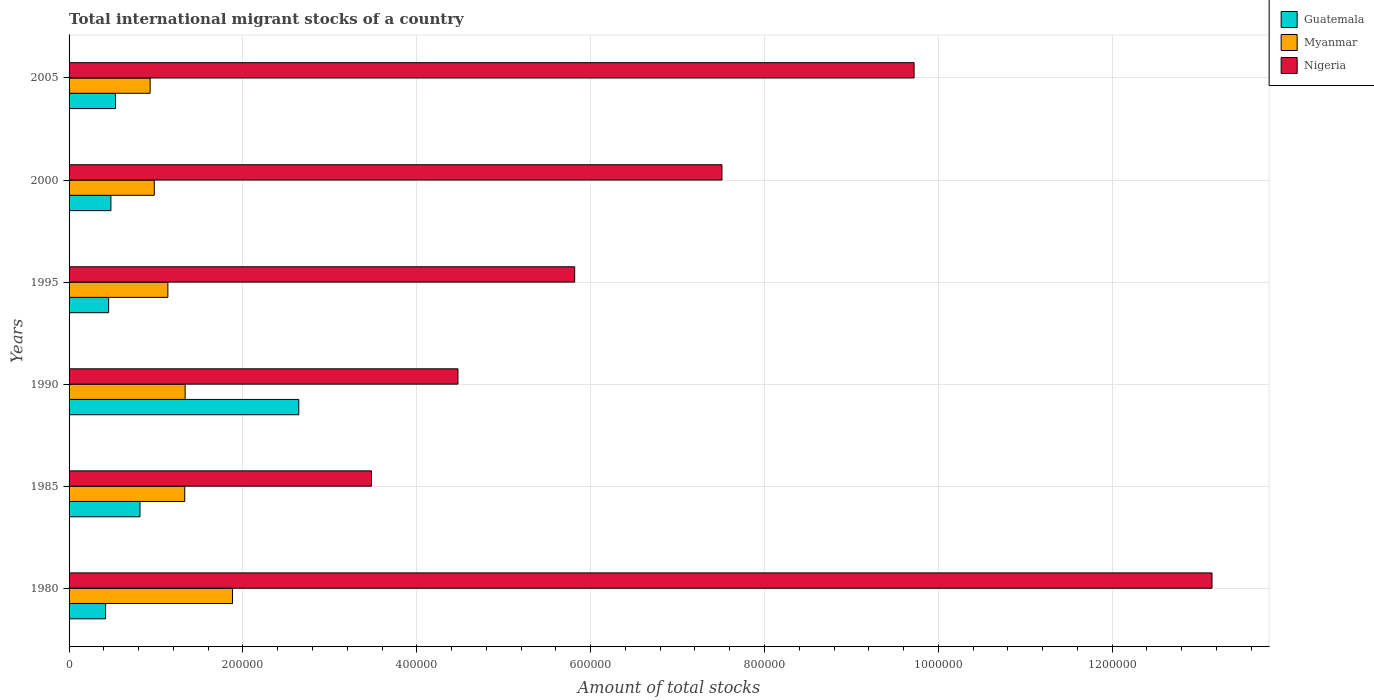Are the number of bars per tick equal to the number of legend labels?
Give a very brief answer. Yes. How many bars are there on the 2nd tick from the bottom?
Keep it short and to the point. 3. What is the label of the 2nd group of bars from the top?
Make the answer very short. 2000. What is the amount of total stocks in in Myanmar in 1990?
Offer a terse response. 1.34e+05. Across all years, what is the maximum amount of total stocks in in Guatemala?
Offer a terse response. 2.64e+05. Across all years, what is the minimum amount of total stocks in in Guatemala?
Give a very brief answer. 4.20e+04. In which year was the amount of total stocks in in Guatemala minimum?
Your response must be concise. 1980. What is the total amount of total stocks in in Nigeria in the graph?
Provide a succinct answer. 4.42e+06. What is the difference between the amount of total stocks in in Guatemala in 2000 and that in 2005?
Offer a terse response. -5318. What is the difference between the amount of total stocks in in Myanmar in 1980 and the amount of total stocks in in Nigeria in 2000?
Keep it short and to the point. -5.63e+05. What is the average amount of total stocks in in Guatemala per year?
Make the answer very short. 8.92e+04. In the year 1980, what is the difference between the amount of total stocks in in Nigeria and amount of total stocks in in Myanmar?
Ensure brevity in your answer.  1.13e+06. What is the ratio of the amount of total stocks in in Nigeria in 1990 to that in 2005?
Give a very brief answer. 0.46. Is the difference between the amount of total stocks in in Nigeria in 1990 and 2000 greater than the difference between the amount of total stocks in in Myanmar in 1990 and 2000?
Keep it short and to the point. No. What is the difference between the highest and the second highest amount of total stocks in in Nigeria?
Your response must be concise. 3.43e+05. What is the difference between the highest and the lowest amount of total stocks in in Guatemala?
Keep it short and to the point. 2.22e+05. In how many years, is the amount of total stocks in in Nigeria greater than the average amount of total stocks in in Nigeria taken over all years?
Give a very brief answer. 3. What does the 2nd bar from the top in 1980 represents?
Make the answer very short. Myanmar. What does the 2nd bar from the bottom in 2005 represents?
Keep it short and to the point. Myanmar. How many bars are there?
Your response must be concise. 18. Are the values on the major ticks of X-axis written in scientific E-notation?
Your answer should be compact. No. Does the graph contain any zero values?
Make the answer very short. No. Does the graph contain grids?
Your answer should be compact. Yes. Where does the legend appear in the graph?
Provide a short and direct response. Top right. How many legend labels are there?
Your answer should be compact. 3. What is the title of the graph?
Your response must be concise. Total international migrant stocks of a country. Does "Uzbekistan" appear as one of the legend labels in the graph?
Your answer should be very brief. No. What is the label or title of the X-axis?
Offer a terse response. Amount of total stocks. What is the Amount of total stocks of Guatemala in 1980?
Your answer should be very brief. 4.20e+04. What is the Amount of total stocks in Myanmar in 1980?
Provide a succinct answer. 1.88e+05. What is the Amount of total stocks of Nigeria in 1980?
Your response must be concise. 1.31e+06. What is the Amount of total stocks in Guatemala in 1985?
Keep it short and to the point. 8.16e+04. What is the Amount of total stocks in Myanmar in 1985?
Make the answer very short. 1.33e+05. What is the Amount of total stocks in Nigeria in 1985?
Provide a short and direct response. 3.48e+05. What is the Amount of total stocks in Guatemala in 1990?
Keep it short and to the point. 2.64e+05. What is the Amount of total stocks of Myanmar in 1990?
Your response must be concise. 1.34e+05. What is the Amount of total stocks of Nigeria in 1990?
Keep it short and to the point. 4.47e+05. What is the Amount of total stocks of Guatemala in 1995?
Your answer should be very brief. 4.55e+04. What is the Amount of total stocks of Myanmar in 1995?
Your response must be concise. 1.14e+05. What is the Amount of total stocks of Nigeria in 1995?
Ensure brevity in your answer.  5.82e+05. What is the Amount of total stocks of Guatemala in 2000?
Give a very brief answer. 4.81e+04. What is the Amount of total stocks in Myanmar in 2000?
Ensure brevity in your answer.  9.80e+04. What is the Amount of total stocks in Nigeria in 2000?
Offer a terse response. 7.51e+05. What is the Amount of total stocks of Guatemala in 2005?
Give a very brief answer. 5.34e+04. What is the Amount of total stocks in Myanmar in 2005?
Offer a terse response. 9.32e+04. What is the Amount of total stocks of Nigeria in 2005?
Your response must be concise. 9.72e+05. Across all years, what is the maximum Amount of total stocks of Guatemala?
Keep it short and to the point. 2.64e+05. Across all years, what is the maximum Amount of total stocks of Myanmar?
Keep it short and to the point. 1.88e+05. Across all years, what is the maximum Amount of total stocks in Nigeria?
Your response must be concise. 1.31e+06. Across all years, what is the minimum Amount of total stocks in Guatemala?
Your answer should be compact. 4.20e+04. Across all years, what is the minimum Amount of total stocks in Myanmar?
Make the answer very short. 9.32e+04. Across all years, what is the minimum Amount of total stocks of Nigeria?
Keep it short and to the point. 3.48e+05. What is the total Amount of total stocks of Guatemala in the graph?
Offer a terse response. 5.35e+05. What is the total Amount of total stocks of Myanmar in the graph?
Provide a succinct answer. 7.60e+05. What is the total Amount of total stocks of Nigeria in the graph?
Your answer should be very brief. 4.42e+06. What is the difference between the Amount of total stocks of Guatemala in 1980 and that in 1985?
Make the answer very short. -3.96e+04. What is the difference between the Amount of total stocks in Myanmar in 1980 and that in 1985?
Your answer should be very brief. 5.50e+04. What is the difference between the Amount of total stocks of Nigeria in 1980 and that in 1985?
Offer a terse response. 9.67e+05. What is the difference between the Amount of total stocks in Guatemala in 1980 and that in 1990?
Make the answer very short. -2.22e+05. What is the difference between the Amount of total stocks of Myanmar in 1980 and that in 1990?
Make the answer very short. 5.45e+04. What is the difference between the Amount of total stocks of Nigeria in 1980 and that in 1990?
Keep it short and to the point. 8.67e+05. What is the difference between the Amount of total stocks of Guatemala in 1980 and that in 1995?
Your answer should be compact. -3512. What is the difference between the Amount of total stocks in Myanmar in 1980 and that in 1995?
Ensure brevity in your answer.  7.44e+04. What is the difference between the Amount of total stocks in Nigeria in 1980 and that in 1995?
Offer a very short reply. 7.33e+05. What is the difference between the Amount of total stocks in Guatemala in 1980 and that in 2000?
Make the answer very short. -6098. What is the difference between the Amount of total stocks in Myanmar in 1980 and that in 2000?
Ensure brevity in your answer.  9.00e+04. What is the difference between the Amount of total stocks of Nigeria in 1980 and that in 2000?
Give a very brief answer. 5.64e+05. What is the difference between the Amount of total stocks of Guatemala in 1980 and that in 2005?
Offer a very short reply. -1.14e+04. What is the difference between the Amount of total stocks in Myanmar in 1980 and that in 2005?
Ensure brevity in your answer.  9.48e+04. What is the difference between the Amount of total stocks of Nigeria in 1980 and that in 2005?
Your answer should be very brief. 3.43e+05. What is the difference between the Amount of total stocks of Guatemala in 1985 and that in 1990?
Offer a terse response. -1.83e+05. What is the difference between the Amount of total stocks in Myanmar in 1985 and that in 1990?
Ensure brevity in your answer.  -485. What is the difference between the Amount of total stocks in Nigeria in 1985 and that in 1990?
Offer a terse response. -9.95e+04. What is the difference between the Amount of total stocks in Guatemala in 1985 and that in 1995?
Keep it short and to the point. 3.61e+04. What is the difference between the Amount of total stocks of Myanmar in 1985 and that in 1995?
Ensure brevity in your answer.  1.94e+04. What is the difference between the Amount of total stocks of Nigeria in 1985 and that in 1995?
Your answer should be compact. -2.34e+05. What is the difference between the Amount of total stocks of Guatemala in 1985 and that in 2000?
Offer a very short reply. 3.35e+04. What is the difference between the Amount of total stocks in Myanmar in 1985 and that in 2000?
Ensure brevity in your answer.  3.50e+04. What is the difference between the Amount of total stocks in Nigeria in 1985 and that in 2000?
Provide a short and direct response. -4.03e+05. What is the difference between the Amount of total stocks in Guatemala in 1985 and that in 2005?
Your answer should be compact. 2.81e+04. What is the difference between the Amount of total stocks in Myanmar in 1985 and that in 2005?
Ensure brevity in your answer.  3.98e+04. What is the difference between the Amount of total stocks of Nigeria in 1985 and that in 2005?
Your response must be concise. -6.24e+05. What is the difference between the Amount of total stocks in Guatemala in 1990 and that in 1995?
Offer a very short reply. 2.19e+05. What is the difference between the Amount of total stocks in Myanmar in 1990 and that in 1995?
Offer a very short reply. 1.99e+04. What is the difference between the Amount of total stocks in Nigeria in 1990 and that in 1995?
Offer a very short reply. -1.34e+05. What is the difference between the Amount of total stocks of Guatemala in 1990 and that in 2000?
Ensure brevity in your answer.  2.16e+05. What is the difference between the Amount of total stocks in Myanmar in 1990 and that in 2000?
Offer a very short reply. 3.55e+04. What is the difference between the Amount of total stocks in Nigeria in 1990 and that in 2000?
Make the answer very short. -3.04e+05. What is the difference between the Amount of total stocks in Guatemala in 1990 and that in 2005?
Ensure brevity in your answer.  2.11e+05. What is the difference between the Amount of total stocks in Myanmar in 1990 and that in 2005?
Your answer should be compact. 4.03e+04. What is the difference between the Amount of total stocks of Nigeria in 1990 and that in 2005?
Offer a terse response. -5.25e+05. What is the difference between the Amount of total stocks in Guatemala in 1995 and that in 2000?
Provide a succinct answer. -2586. What is the difference between the Amount of total stocks in Myanmar in 1995 and that in 2000?
Offer a very short reply. 1.56e+04. What is the difference between the Amount of total stocks of Nigeria in 1995 and that in 2000?
Give a very brief answer. -1.69e+05. What is the difference between the Amount of total stocks in Guatemala in 1995 and that in 2005?
Offer a terse response. -7904. What is the difference between the Amount of total stocks in Myanmar in 1995 and that in 2005?
Your response must be concise. 2.04e+04. What is the difference between the Amount of total stocks in Nigeria in 1995 and that in 2005?
Provide a short and direct response. -3.90e+05. What is the difference between the Amount of total stocks of Guatemala in 2000 and that in 2005?
Ensure brevity in your answer.  -5318. What is the difference between the Amount of total stocks of Myanmar in 2000 and that in 2005?
Make the answer very short. 4781. What is the difference between the Amount of total stocks of Nigeria in 2000 and that in 2005?
Keep it short and to the point. -2.21e+05. What is the difference between the Amount of total stocks of Guatemala in 1980 and the Amount of total stocks of Myanmar in 1985?
Ensure brevity in your answer.  -9.10e+04. What is the difference between the Amount of total stocks in Guatemala in 1980 and the Amount of total stocks in Nigeria in 1985?
Ensure brevity in your answer.  -3.06e+05. What is the difference between the Amount of total stocks in Myanmar in 1980 and the Amount of total stocks in Nigeria in 1985?
Provide a succinct answer. -1.60e+05. What is the difference between the Amount of total stocks in Guatemala in 1980 and the Amount of total stocks in Myanmar in 1990?
Ensure brevity in your answer.  -9.15e+04. What is the difference between the Amount of total stocks in Guatemala in 1980 and the Amount of total stocks in Nigeria in 1990?
Your response must be concise. -4.05e+05. What is the difference between the Amount of total stocks in Myanmar in 1980 and the Amount of total stocks in Nigeria in 1990?
Provide a succinct answer. -2.59e+05. What is the difference between the Amount of total stocks of Guatemala in 1980 and the Amount of total stocks of Myanmar in 1995?
Provide a short and direct response. -7.16e+04. What is the difference between the Amount of total stocks in Guatemala in 1980 and the Amount of total stocks in Nigeria in 1995?
Ensure brevity in your answer.  -5.40e+05. What is the difference between the Amount of total stocks in Myanmar in 1980 and the Amount of total stocks in Nigeria in 1995?
Give a very brief answer. -3.94e+05. What is the difference between the Amount of total stocks of Guatemala in 1980 and the Amount of total stocks of Myanmar in 2000?
Provide a short and direct response. -5.60e+04. What is the difference between the Amount of total stocks in Guatemala in 1980 and the Amount of total stocks in Nigeria in 2000?
Keep it short and to the point. -7.09e+05. What is the difference between the Amount of total stocks in Myanmar in 1980 and the Amount of total stocks in Nigeria in 2000?
Keep it short and to the point. -5.63e+05. What is the difference between the Amount of total stocks of Guatemala in 1980 and the Amount of total stocks of Myanmar in 2005?
Offer a very short reply. -5.12e+04. What is the difference between the Amount of total stocks in Guatemala in 1980 and the Amount of total stocks in Nigeria in 2005?
Give a very brief answer. -9.30e+05. What is the difference between the Amount of total stocks of Myanmar in 1980 and the Amount of total stocks of Nigeria in 2005?
Keep it short and to the point. -7.84e+05. What is the difference between the Amount of total stocks of Guatemala in 1985 and the Amount of total stocks of Myanmar in 1990?
Provide a succinct answer. -5.20e+04. What is the difference between the Amount of total stocks of Guatemala in 1985 and the Amount of total stocks of Nigeria in 1990?
Your answer should be compact. -3.66e+05. What is the difference between the Amount of total stocks in Myanmar in 1985 and the Amount of total stocks in Nigeria in 1990?
Your answer should be very brief. -3.14e+05. What is the difference between the Amount of total stocks of Guatemala in 1985 and the Amount of total stocks of Myanmar in 1995?
Offer a very short reply. -3.21e+04. What is the difference between the Amount of total stocks of Guatemala in 1985 and the Amount of total stocks of Nigeria in 1995?
Make the answer very short. -5.00e+05. What is the difference between the Amount of total stocks in Myanmar in 1985 and the Amount of total stocks in Nigeria in 1995?
Keep it short and to the point. -4.49e+05. What is the difference between the Amount of total stocks in Guatemala in 1985 and the Amount of total stocks in Myanmar in 2000?
Your answer should be very brief. -1.64e+04. What is the difference between the Amount of total stocks of Guatemala in 1985 and the Amount of total stocks of Nigeria in 2000?
Your answer should be compact. -6.70e+05. What is the difference between the Amount of total stocks in Myanmar in 1985 and the Amount of total stocks in Nigeria in 2000?
Your answer should be very brief. -6.18e+05. What is the difference between the Amount of total stocks in Guatemala in 1985 and the Amount of total stocks in Myanmar in 2005?
Keep it short and to the point. -1.17e+04. What is the difference between the Amount of total stocks in Guatemala in 1985 and the Amount of total stocks in Nigeria in 2005?
Provide a short and direct response. -8.91e+05. What is the difference between the Amount of total stocks of Myanmar in 1985 and the Amount of total stocks of Nigeria in 2005?
Give a very brief answer. -8.39e+05. What is the difference between the Amount of total stocks of Guatemala in 1990 and the Amount of total stocks of Myanmar in 1995?
Your response must be concise. 1.51e+05. What is the difference between the Amount of total stocks in Guatemala in 1990 and the Amount of total stocks in Nigeria in 1995?
Offer a terse response. -3.17e+05. What is the difference between the Amount of total stocks of Myanmar in 1990 and the Amount of total stocks of Nigeria in 1995?
Ensure brevity in your answer.  -4.48e+05. What is the difference between the Amount of total stocks of Guatemala in 1990 and the Amount of total stocks of Myanmar in 2000?
Offer a terse response. 1.66e+05. What is the difference between the Amount of total stocks of Guatemala in 1990 and the Amount of total stocks of Nigeria in 2000?
Keep it short and to the point. -4.87e+05. What is the difference between the Amount of total stocks of Myanmar in 1990 and the Amount of total stocks of Nigeria in 2000?
Your answer should be very brief. -6.18e+05. What is the difference between the Amount of total stocks of Guatemala in 1990 and the Amount of total stocks of Myanmar in 2005?
Make the answer very short. 1.71e+05. What is the difference between the Amount of total stocks in Guatemala in 1990 and the Amount of total stocks in Nigeria in 2005?
Offer a very short reply. -7.08e+05. What is the difference between the Amount of total stocks in Myanmar in 1990 and the Amount of total stocks in Nigeria in 2005?
Offer a terse response. -8.39e+05. What is the difference between the Amount of total stocks of Guatemala in 1995 and the Amount of total stocks of Myanmar in 2000?
Offer a very short reply. -5.25e+04. What is the difference between the Amount of total stocks of Guatemala in 1995 and the Amount of total stocks of Nigeria in 2000?
Your answer should be compact. -7.06e+05. What is the difference between the Amount of total stocks in Myanmar in 1995 and the Amount of total stocks in Nigeria in 2000?
Your response must be concise. -6.37e+05. What is the difference between the Amount of total stocks of Guatemala in 1995 and the Amount of total stocks of Myanmar in 2005?
Provide a succinct answer. -4.77e+04. What is the difference between the Amount of total stocks in Guatemala in 1995 and the Amount of total stocks in Nigeria in 2005?
Your response must be concise. -9.27e+05. What is the difference between the Amount of total stocks in Myanmar in 1995 and the Amount of total stocks in Nigeria in 2005?
Provide a short and direct response. -8.58e+05. What is the difference between the Amount of total stocks of Guatemala in 2000 and the Amount of total stocks of Myanmar in 2005?
Your answer should be very brief. -4.51e+04. What is the difference between the Amount of total stocks of Guatemala in 2000 and the Amount of total stocks of Nigeria in 2005?
Provide a short and direct response. -9.24e+05. What is the difference between the Amount of total stocks of Myanmar in 2000 and the Amount of total stocks of Nigeria in 2005?
Your answer should be very brief. -8.74e+05. What is the average Amount of total stocks in Guatemala per year?
Your answer should be very brief. 8.92e+04. What is the average Amount of total stocks of Myanmar per year?
Provide a succinct answer. 1.27e+05. What is the average Amount of total stocks in Nigeria per year?
Your answer should be very brief. 7.36e+05. In the year 1980, what is the difference between the Amount of total stocks of Guatemala and Amount of total stocks of Myanmar?
Ensure brevity in your answer.  -1.46e+05. In the year 1980, what is the difference between the Amount of total stocks of Guatemala and Amount of total stocks of Nigeria?
Provide a succinct answer. -1.27e+06. In the year 1980, what is the difference between the Amount of total stocks in Myanmar and Amount of total stocks in Nigeria?
Your answer should be compact. -1.13e+06. In the year 1985, what is the difference between the Amount of total stocks in Guatemala and Amount of total stocks in Myanmar?
Keep it short and to the point. -5.15e+04. In the year 1985, what is the difference between the Amount of total stocks in Guatemala and Amount of total stocks in Nigeria?
Offer a very short reply. -2.66e+05. In the year 1985, what is the difference between the Amount of total stocks in Myanmar and Amount of total stocks in Nigeria?
Your response must be concise. -2.15e+05. In the year 1990, what is the difference between the Amount of total stocks in Guatemala and Amount of total stocks in Myanmar?
Your response must be concise. 1.31e+05. In the year 1990, what is the difference between the Amount of total stocks of Guatemala and Amount of total stocks of Nigeria?
Your response must be concise. -1.83e+05. In the year 1990, what is the difference between the Amount of total stocks in Myanmar and Amount of total stocks in Nigeria?
Offer a terse response. -3.14e+05. In the year 1995, what is the difference between the Amount of total stocks of Guatemala and Amount of total stocks of Myanmar?
Keep it short and to the point. -6.81e+04. In the year 1995, what is the difference between the Amount of total stocks of Guatemala and Amount of total stocks of Nigeria?
Your answer should be compact. -5.36e+05. In the year 1995, what is the difference between the Amount of total stocks of Myanmar and Amount of total stocks of Nigeria?
Your answer should be compact. -4.68e+05. In the year 2000, what is the difference between the Amount of total stocks of Guatemala and Amount of total stocks of Myanmar?
Your response must be concise. -4.99e+04. In the year 2000, what is the difference between the Amount of total stocks in Guatemala and Amount of total stocks in Nigeria?
Provide a short and direct response. -7.03e+05. In the year 2000, what is the difference between the Amount of total stocks in Myanmar and Amount of total stocks in Nigeria?
Provide a succinct answer. -6.53e+05. In the year 2005, what is the difference between the Amount of total stocks in Guatemala and Amount of total stocks in Myanmar?
Your response must be concise. -3.98e+04. In the year 2005, what is the difference between the Amount of total stocks of Guatemala and Amount of total stocks of Nigeria?
Offer a terse response. -9.19e+05. In the year 2005, what is the difference between the Amount of total stocks in Myanmar and Amount of total stocks in Nigeria?
Ensure brevity in your answer.  -8.79e+05. What is the ratio of the Amount of total stocks in Guatemala in 1980 to that in 1985?
Your answer should be very brief. 0.52. What is the ratio of the Amount of total stocks in Myanmar in 1980 to that in 1985?
Give a very brief answer. 1.41. What is the ratio of the Amount of total stocks in Nigeria in 1980 to that in 1985?
Your response must be concise. 3.78. What is the ratio of the Amount of total stocks of Guatemala in 1980 to that in 1990?
Offer a terse response. 0.16. What is the ratio of the Amount of total stocks of Myanmar in 1980 to that in 1990?
Your response must be concise. 1.41. What is the ratio of the Amount of total stocks in Nigeria in 1980 to that in 1990?
Ensure brevity in your answer.  2.94. What is the ratio of the Amount of total stocks in Guatemala in 1980 to that in 1995?
Your response must be concise. 0.92. What is the ratio of the Amount of total stocks of Myanmar in 1980 to that in 1995?
Keep it short and to the point. 1.65. What is the ratio of the Amount of total stocks of Nigeria in 1980 to that in 1995?
Offer a very short reply. 2.26. What is the ratio of the Amount of total stocks in Guatemala in 1980 to that in 2000?
Offer a terse response. 0.87. What is the ratio of the Amount of total stocks in Myanmar in 1980 to that in 2000?
Make the answer very short. 1.92. What is the ratio of the Amount of total stocks of Nigeria in 1980 to that in 2000?
Your answer should be compact. 1.75. What is the ratio of the Amount of total stocks in Guatemala in 1980 to that in 2005?
Your response must be concise. 0.79. What is the ratio of the Amount of total stocks in Myanmar in 1980 to that in 2005?
Offer a very short reply. 2.02. What is the ratio of the Amount of total stocks in Nigeria in 1980 to that in 2005?
Your response must be concise. 1.35. What is the ratio of the Amount of total stocks in Guatemala in 1985 to that in 1990?
Provide a succinct answer. 0.31. What is the ratio of the Amount of total stocks in Myanmar in 1985 to that in 1990?
Make the answer very short. 1. What is the ratio of the Amount of total stocks of Nigeria in 1985 to that in 1990?
Provide a short and direct response. 0.78. What is the ratio of the Amount of total stocks in Guatemala in 1985 to that in 1995?
Your answer should be compact. 1.79. What is the ratio of the Amount of total stocks of Myanmar in 1985 to that in 1995?
Your answer should be very brief. 1.17. What is the ratio of the Amount of total stocks in Nigeria in 1985 to that in 1995?
Offer a terse response. 0.6. What is the ratio of the Amount of total stocks in Guatemala in 1985 to that in 2000?
Provide a succinct answer. 1.7. What is the ratio of the Amount of total stocks in Myanmar in 1985 to that in 2000?
Provide a short and direct response. 1.36. What is the ratio of the Amount of total stocks in Nigeria in 1985 to that in 2000?
Your response must be concise. 0.46. What is the ratio of the Amount of total stocks of Guatemala in 1985 to that in 2005?
Your answer should be compact. 1.53. What is the ratio of the Amount of total stocks of Myanmar in 1985 to that in 2005?
Keep it short and to the point. 1.43. What is the ratio of the Amount of total stocks in Nigeria in 1985 to that in 2005?
Offer a terse response. 0.36. What is the ratio of the Amount of total stocks of Guatemala in 1990 to that in 1995?
Give a very brief answer. 5.8. What is the ratio of the Amount of total stocks in Myanmar in 1990 to that in 1995?
Provide a short and direct response. 1.17. What is the ratio of the Amount of total stocks of Nigeria in 1990 to that in 1995?
Keep it short and to the point. 0.77. What is the ratio of the Amount of total stocks of Guatemala in 1990 to that in 2000?
Give a very brief answer. 5.49. What is the ratio of the Amount of total stocks of Myanmar in 1990 to that in 2000?
Offer a terse response. 1.36. What is the ratio of the Amount of total stocks in Nigeria in 1990 to that in 2000?
Give a very brief answer. 0.6. What is the ratio of the Amount of total stocks of Guatemala in 1990 to that in 2005?
Your answer should be compact. 4.95. What is the ratio of the Amount of total stocks in Myanmar in 1990 to that in 2005?
Offer a very short reply. 1.43. What is the ratio of the Amount of total stocks in Nigeria in 1990 to that in 2005?
Provide a short and direct response. 0.46. What is the ratio of the Amount of total stocks of Guatemala in 1995 to that in 2000?
Ensure brevity in your answer.  0.95. What is the ratio of the Amount of total stocks in Myanmar in 1995 to that in 2000?
Ensure brevity in your answer.  1.16. What is the ratio of the Amount of total stocks of Nigeria in 1995 to that in 2000?
Offer a terse response. 0.77. What is the ratio of the Amount of total stocks of Guatemala in 1995 to that in 2005?
Provide a succinct answer. 0.85. What is the ratio of the Amount of total stocks of Myanmar in 1995 to that in 2005?
Offer a very short reply. 1.22. What is the ratio of the Amount of total stocks of Nigeria in 1995 to that in 2005?
Provide a short and direct response. 0.6. What is the ratio of the Amount of total stocks in Guatemala in 2000 to that in 2005?
Your answer should be compact. 0.9. What is the ratio of the Amount of total stocks in Myanmar in 2000 to that in 2005?
Provide a short and direct response. 1.05. What is the ratio of the Amount of total stocks in Nigeria in 2000 to that in 2005?
Your answer should be compact. 0.77. What is the difference between the highest and the second highest Amount of total stocks in Guatemala?
Offer a very short reply. 1.83e+05. What is the difference between the highest and the second highest Amount of total stocks of Myanmar?
Offer a terse response. 5.45e+04. What is the difference between the highest and the second highest Amount of total stocks of Nigeria?
Your answer should be very brief. 3.43e+05. What is the difference between the highest and the lowest Amount of total stocks in Guatemala?
Provide a succinct answer. 2.22e+05. What is the difference between the highest and the lowest Amount of total stocks of Myanmar?
Your answer should be compact. 9.48e+04. What is the difference between the highest and the lowest Amount of total stocks in Nigeria?
Ensure brevity in your answer.  9.67e+05. 